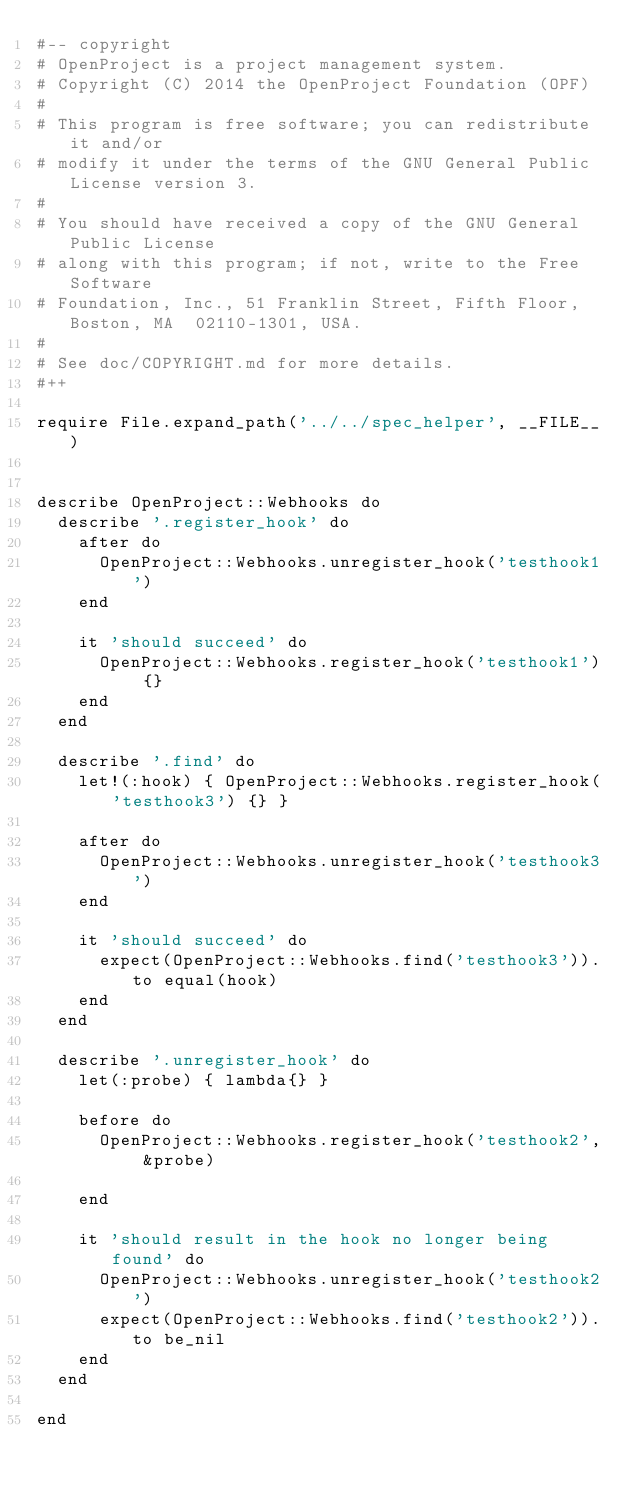<code> <loc_0><loc_0><loc_500><loc_500><_Ruby_>#-- copyright
# OpenProject is a project management system.
# Copyright (C) 2014 the OpenProject Foundation (OPF)
#
# This program is free software; you can redistribute it and/or
# modify it under the terms of the GNU General Public License version 3.
#
# You should have received a copy of the GNU General Public License
# along with this program; if not, write to the Free Software
# Foundation, Inc., 51 Franklin Street, Fifth Floor, Boston, MA  02110-1301, USA.
#
# See doc/COPYRIGHT.md for more details.
#++

require File.expand_path('../../spec_helper', __FILE__)


describe OpenProject::Webhooks do
  describe '.register_hook' do
    after do
      OpenProject::Webhooks.unregister_hook('testhook1')
    end

    it 'should succeed' do
      OpenProject::Webhooks.register_hook('testhook1') {}
    end
  end

  describe '.find' do
    let!(:hook) { OpenProject::Webhooks.register_hook('testhook3') {} }

    after do
      OpenProject::Webhooks.unregister_hook('testhook3')
    end

    it 'should succeed' do
      expect(OpenProject::Webhooks.find('testhook3')).to equal(hook)
    end
  end

  describe '.unregister_hook' do
    let(:probe) { lambda{} }

    before do
      OpenProject::Webhooks.register_hook('testhook2', &probe)

    end

    it 'should result in the hook no longer being found' do
      OpenProject::Webhooks.unregister_hook('testhook2')
      expect(OpenProject::Webhooks.find('testhook2')).to be_nil
    end
  end

end
</code> 